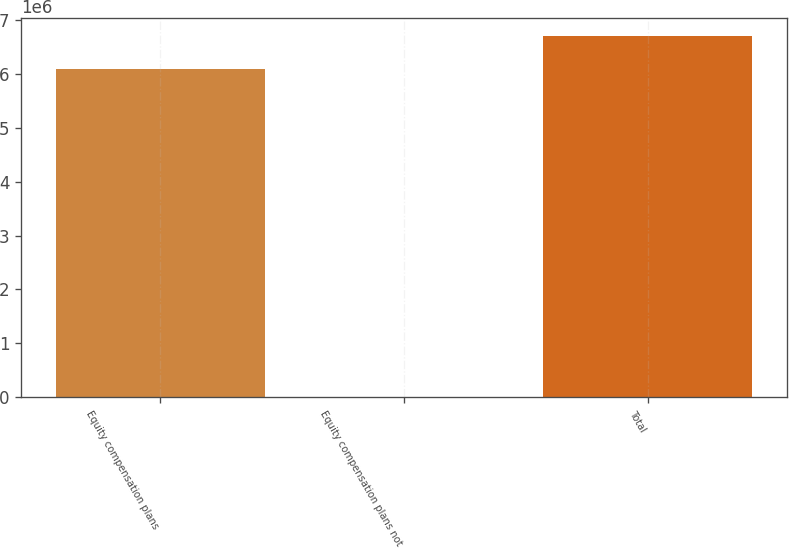<chart> <loc_0><loc_0><loc_500><loc_500><bar_chart><fcel>Equity compensation plans<fcel>Equity compensation plans not<fcel>Total<nl><fcel>6.09934e+06<fcel>1.86<fcel>6.70928e+06<nl></chart> 